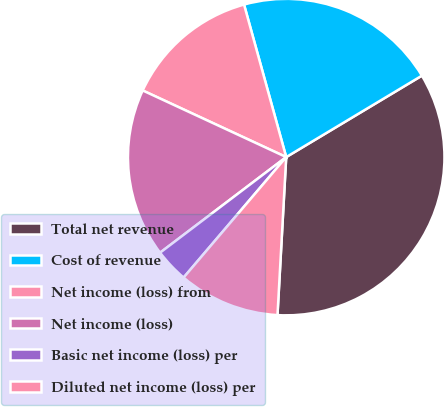Convert chart. <chart><loc_0><loc_0><loc_500><loc_500><pie_chart><fcel>Total net revenue<fcel>Cost of revenue<fcel>Net income (loss) from<fcel>Net income (loss)<fcel>Basic net income (loss) per<fcel>Diluted net income (loss) per<nl><fcel>34.48%<fcel>20.69%<fcel>13.79%<fcel>17.24%<fcel>3.45%<fcel>10.35%<nl></chart> 